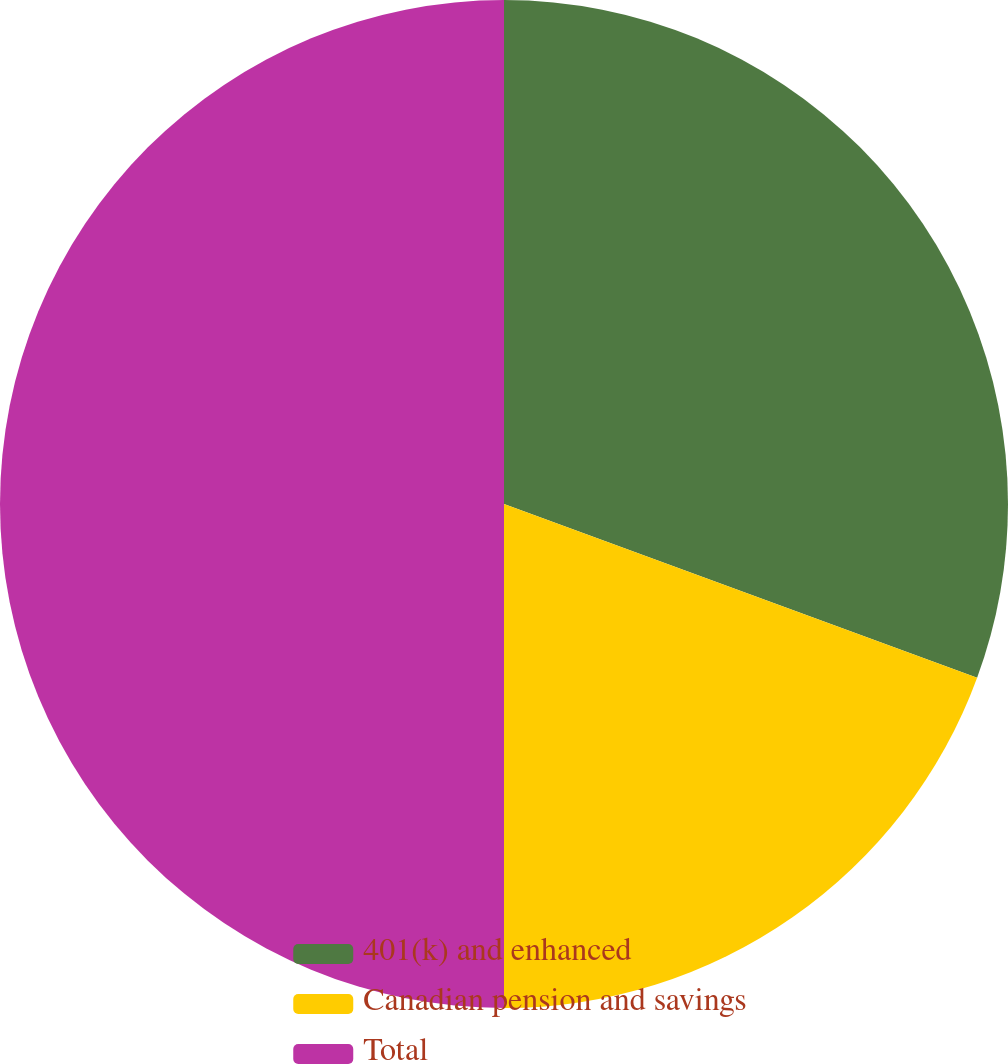<chart> <loc_0><loc_0><loc_500><loc_500><pie_chart><fcel>401(k) and enhanced<fcel>Canadian pension and savings<fcel>Total<nl><fcel>30.6%<fcel>19.4%<fcel>50.0%<nl></chart> 